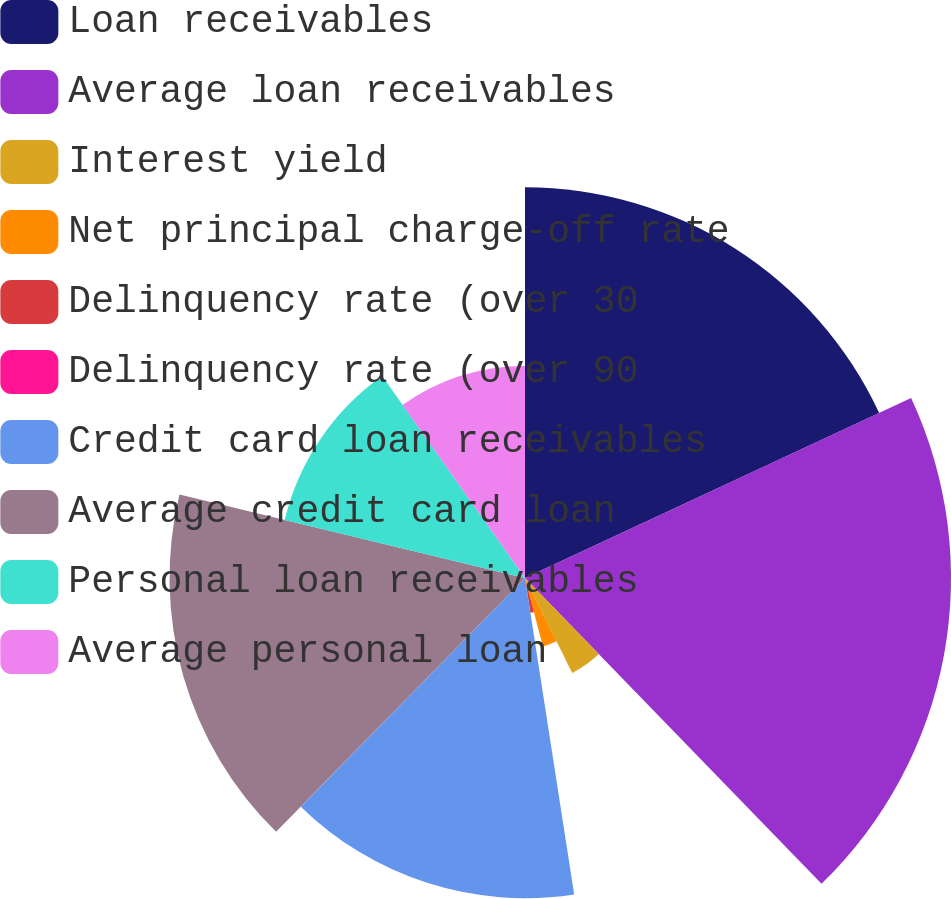Convert chart. <chart><loc_0><loc_0><loc_500><loc_500><pie_chart><fcel>Loan receivables<fcel>Average loan receivables<fcel>Interest yield<fcel>Net principal charge-off rate<fcel>Delinquency rate (over 30<fcel>Delinquency rate (over 90<fcel>Credit card loan receivables<fcel>Average credit card loan<fcel>Personal loan receivables<fcel>Average personal loan<nl><fcel>18.06%<fcel>19.69%<fcel>4.9%<fcel>3.27%<fcel>1.63%<fcel>0.0%<fcel>14.8%<fcel>16.43%<fcel>11.43%<fcel>9.8%<nl></chart> 